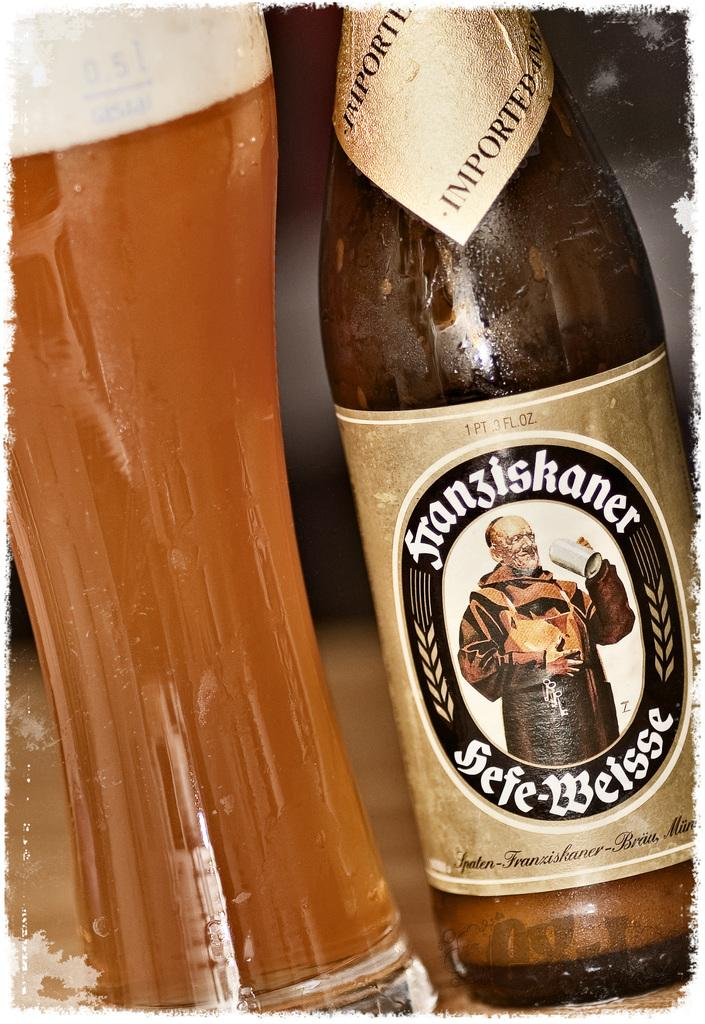Provide a one-sentence caption for the provided image. A bottle of beer says on the neck label that it was imported. 